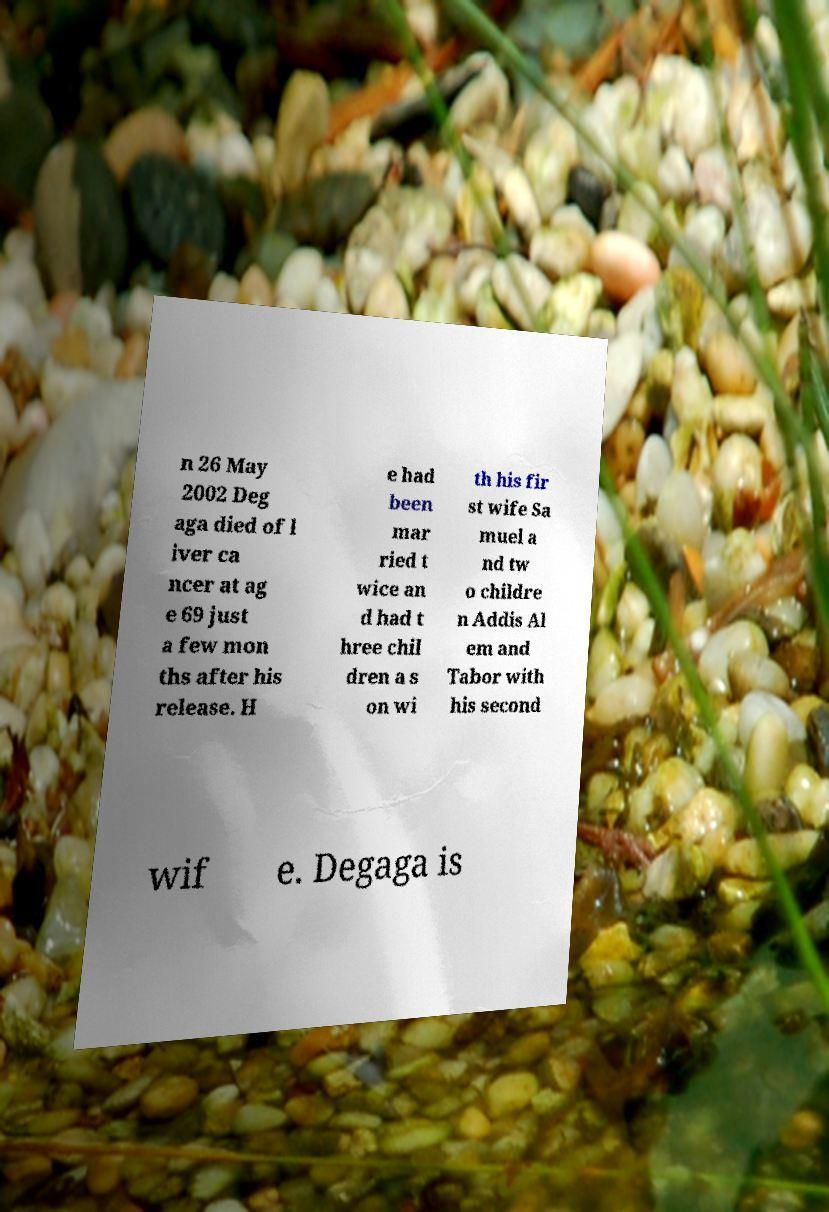For documentation purposes, I need the text within this image transcribed. Could you provide that? n 26 May 2002 Deg aga died of l iver ca ncer at ag e 69 just a few mon ths after his release. H e had been mar ried t wice an d had t hree chil dren a s on wi th his fir st wife Sa muel a nd tw o childre n Addis Al em and Tabor with his second wif e. Degaga is 